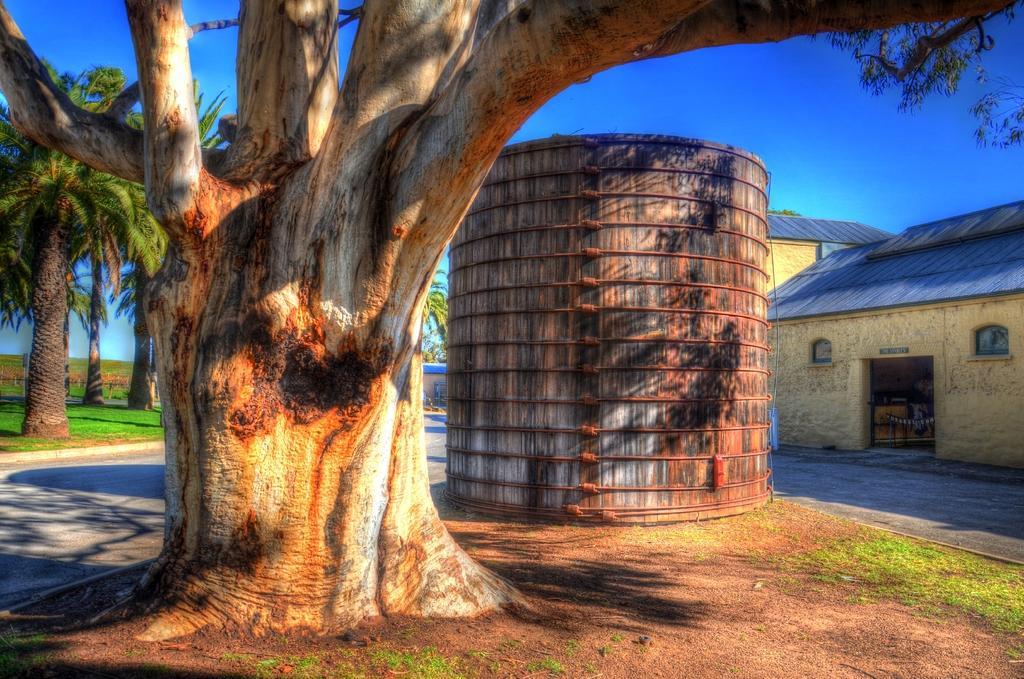In one or two sentences, can you explain what this image depicts? In this image I can see the tree and an object. To the right I can see the houses. In the background I can see many trees and the blue sky. 